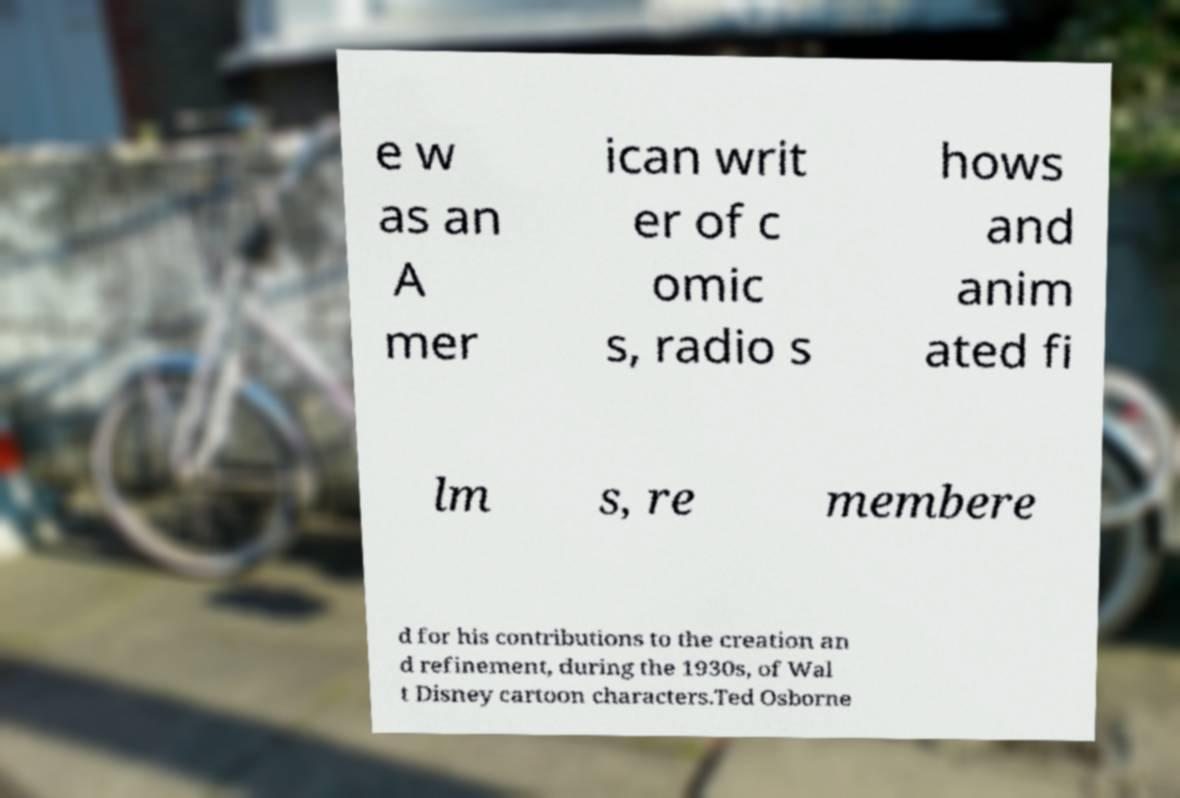There's text embedded in this image that I need extracted. Can you transcribe it verbatim? e w as an A mer ican writ er of c omic s, radio s hows and anim ated fi lm s, re membere d for his contributions to the creation an d refinement, during the 1930s, of Wal t Disney cartoon characters.Ted Osborne 